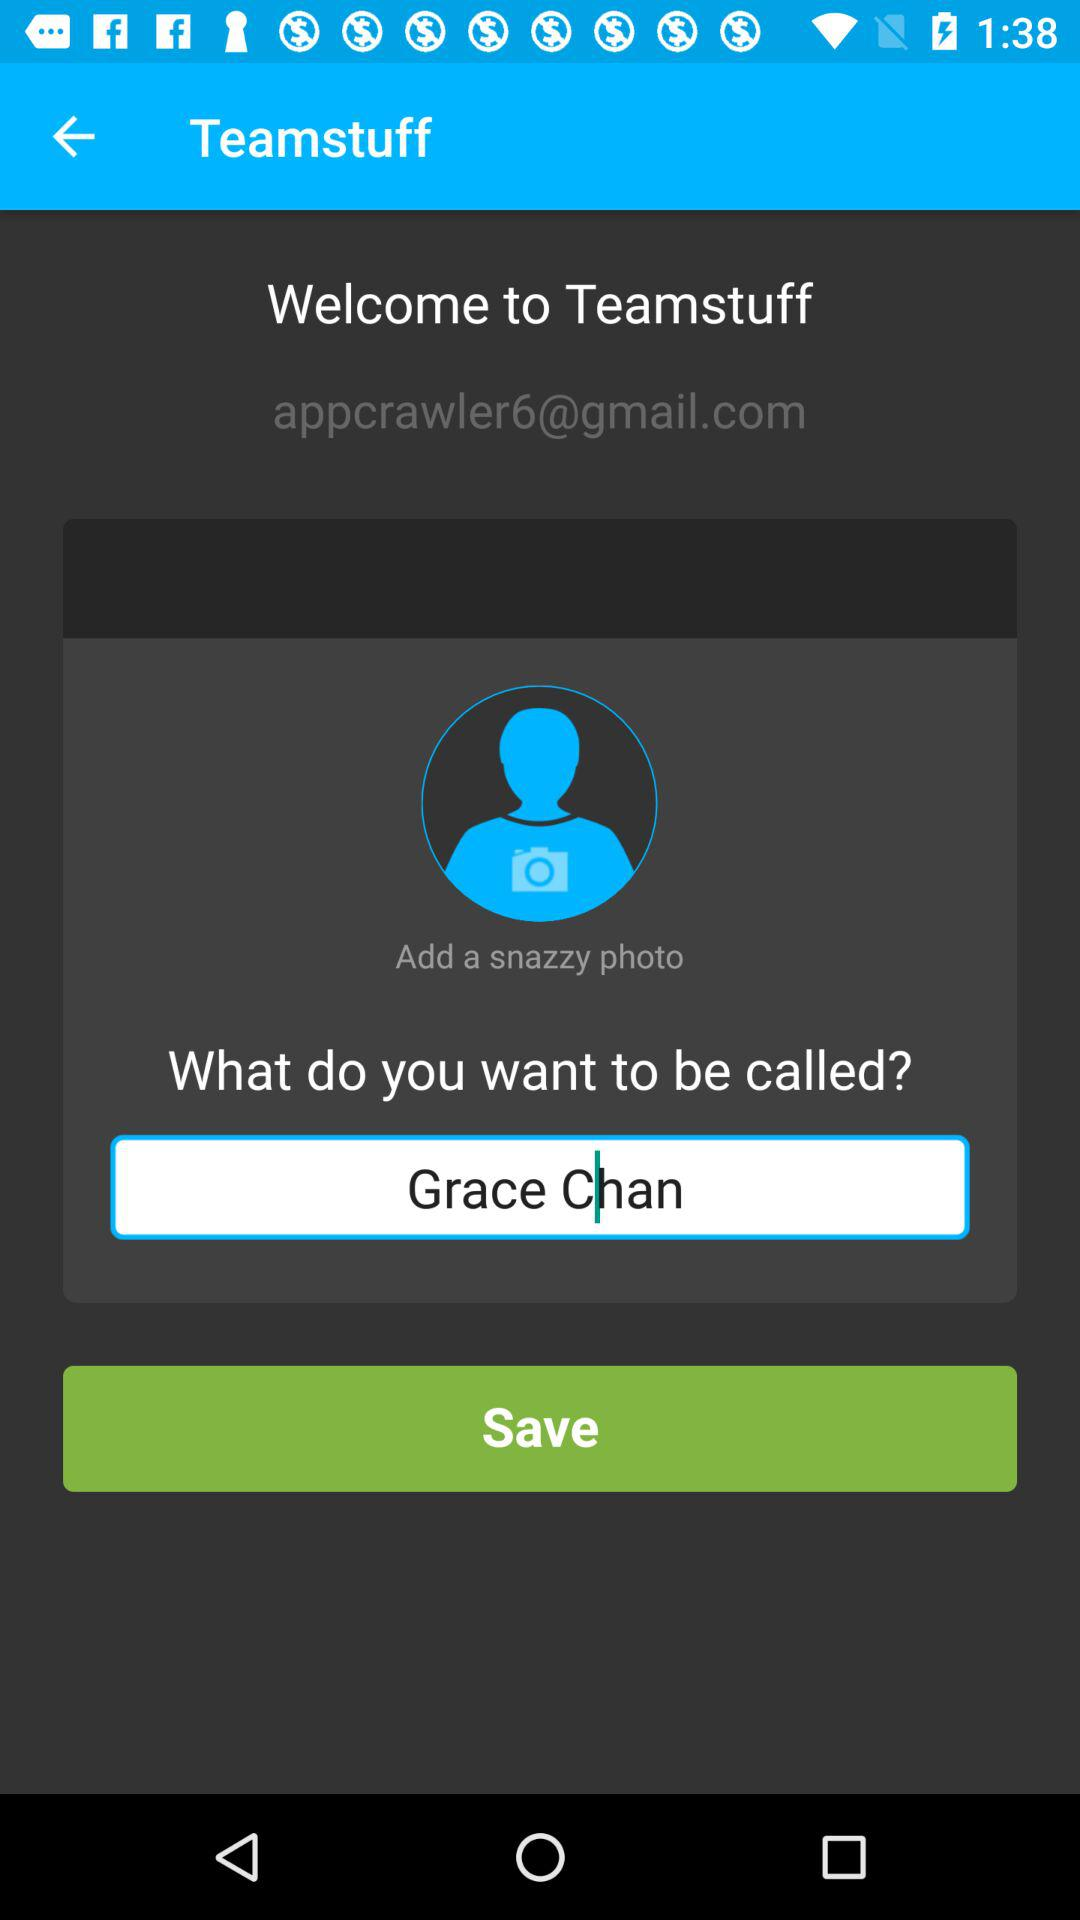What is the user name? The user name is Grace Chan. 